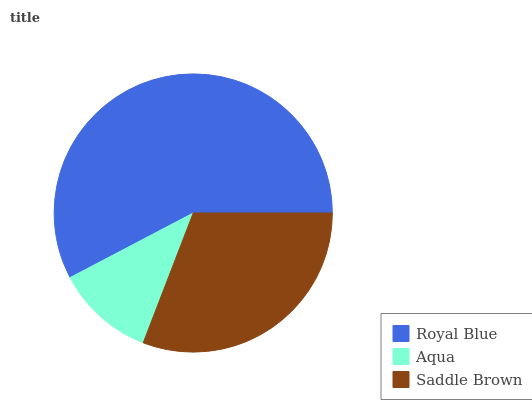Is Aqua the minimum?
Answer yes or no. Yes. Is Royal Blue the maximum?
Answer yes or no. Yes. Is Saddle Brown the minimum?
Answer yes or no. No. Is Saddle Brown the maximum?
Answer yes or no. No. Is Saddle Brown greater than Aqua?
Answer yes or no. Yes. Is Aqua less than Saddle Brown?
Answer yes or no. Yes. Is Aqua greater than Saddle Brown?
Answer yes or no. No. Is Saddle Brown less than Aqua?
Answer yes or no. No. Is Saddle Brown the high median?
Answer yes or no. Yes. Is Saddle Brown the low median?
Answer yes or no. Yes. Is Aqua the high median?
Answer yes or no. No. Is Aqua the low median?
Answer yes or no. No. 